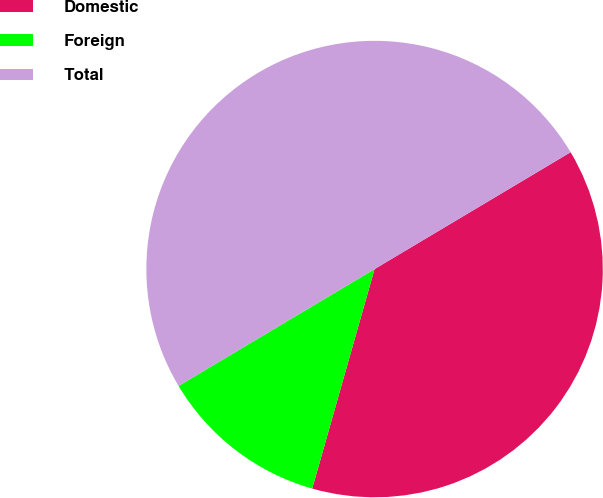Convert chart to OTSL. <chart><loc_0><loc_0><loc_500><loc_500><pie_chart><fcel>Domestic<fcel>Foreign<fcel>Total<nl><fcel>37.96%<fcel>12.04%<fcel>50.0%<nl></chart> 